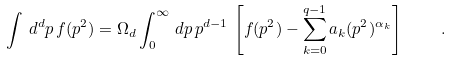<formula> <loc_0><loc_0><loc_500><loc_500>\int \, d ^ { d } p \, f ( p ^ { 2 } ) = \Omega _ { d } \int _ { 0 } ^ { \infty } \, d p \, p ^ { d - 1 } \, \left [ f ( p ^ { 2 } ) - \sum _ { k = 0 } ^ { q - 1 } a _ { k } ( p ^ { 2 } ) ^ { \alpha _ { k } } \right ] \quad .</formula> 